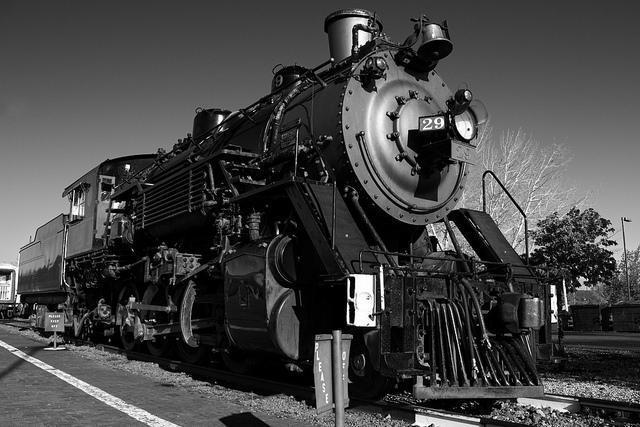How many people are in the picture?
Give a very brief answer. 0. 